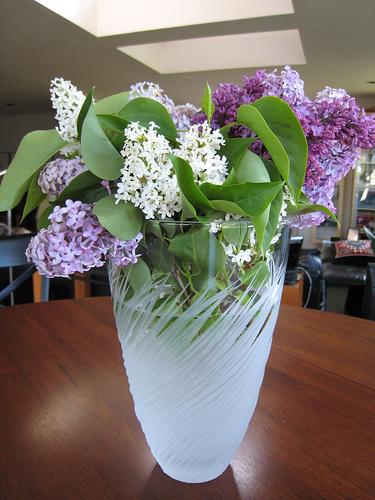Is the vase clear?
Answer briefly. No. What kind of flowers are these?
Answer briefly. Lilacs. How many flowers are there?
Be succinct. 12. 